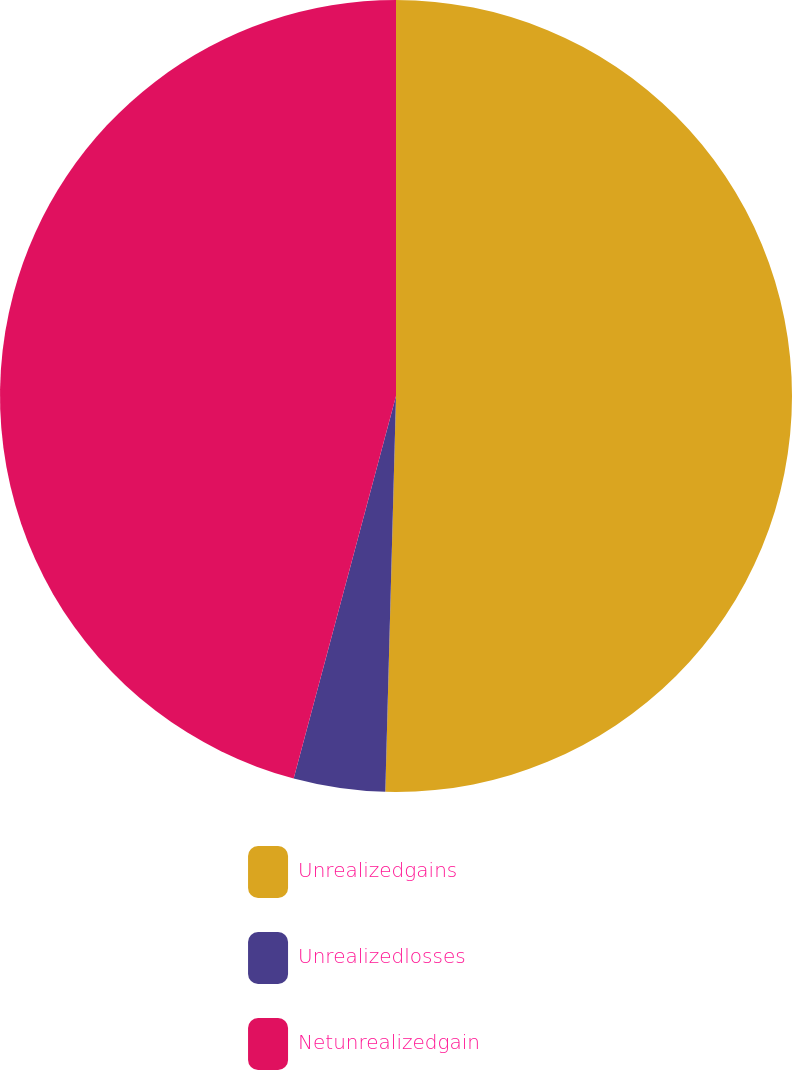Convert chart to OTSL. <chart><loc_0><loc_0><loc_500><loc_500><pie_chart><fcel>Unrealizedgains<fcel>Unrealizedlosses<fcel>Netunrealizedgain<nl><fcel>50.43%<fcel>3.73%<fcel>45.84%<nl></chart> 